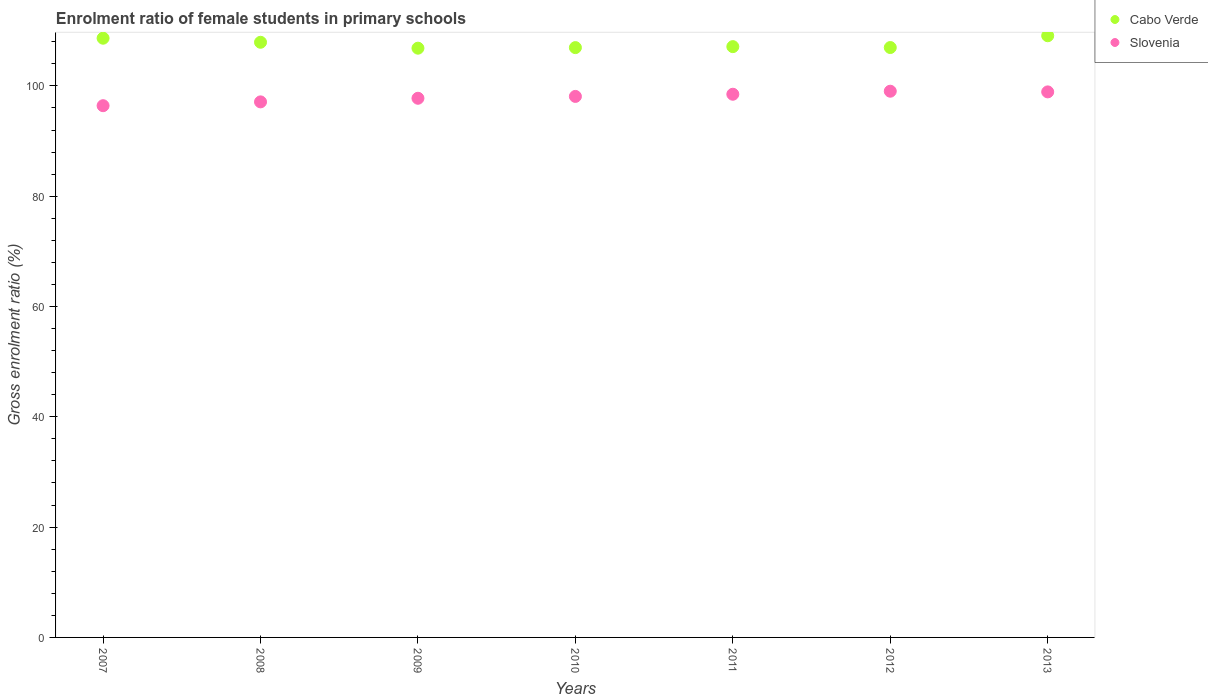What is the enrolment ratio of female students in primary schools in Slovenia in 2007?
Your answer should be very brief. 96.41. Across all years, what is the maximum enrolment ratio of female students in primary schools in Slovenia?
Provide a succinct answer. 99.03. Across all years, what is the minimum enrolment ratio of female students in primary schools in Cabo Verde?
Provide a succinct answer. 106.84. What is the total enrolment ratio of female students in primary schools in Cabo Verde in the graph?
Your answer should be compact. 753.49. What is the difference between the enrolment ratio of female students in primary schools in Cabo Verde in 2009 and that in 2010?
Ensure brevity in your answer.  -0.1. What is the difference between the enrolment ratio of female students in primary schools in Slovenia in 2013 and the enrolment ratio of female students in primary schools in Cabo Verde in 2008?
Give a very brief answer. -9. What is the average enrolment ratio of female students in primary schools in Cabo Verde per year?
Provide a short and direct response. 107.64. In the year 2007, what is the difference between the enrolment ratio of female students in primary schools in Cabo Verde and enrolment ratio of female students in primary schools in Slovenia?
Keep it short and to the point. 12.23. What is the ratio of the enrolment ratio of female students in primary schools in Cabo Verde in 2007 to that in 2010?
Your answer should be very brief. 1.02. What is the difference between the highest and the second highest enrolment ratio of female students in primary schools in Cabo Verde?
Give a very brief answer. 0.45. What is the difference between the highest and the lowest enrolment ratio of female students in primary schools in Cabo Verde?
Your response must be concise. 2.25. In how many years, is the enrolment ratio of female students in primary schools in Cabo Verde greater than the average enrolment ratio of female students in primary schools in Cabo Verde taken over all years?
Ensure brevity in your answer.  3. Is the sum of the enrolment ratio of female students in primary schools in Cabo Verde in 2007 and 2013 greater than the maximum enrolment ratio of female students in primary schools in Slovenia across all years?
Keep it short and to the point. Yes. Is the enrolment ratio of female students in primary schools in Cabo Verde strictly greater than the enrolment ratio of female students in primary schools in Slovenia over the years?
Provide a succinct answer. Yes. Is the enrolment ratio of female students in primary schools in Slovenia strictly less than the enrolment ratio of female students in primary schools in Cabo Verde over the years?
Your answer should be very brief. Yes. What is the difference between two consecutive major ticks on the Y-axis?
Give a very brief answer. 20. Are the values on the major ticks of Y-axis written in scientific E-notation?
Provide a short and direct response. No. Does the graph contain any zero values?
Make the answer very short. No. What is the title of the graph?
Ensure brevity in your answer.  Enrolment ratio of female students in primary schools. Does "Euro area" appear as one of the legend labels in the graph?
Ensure brevity in your answer.  No. What is the label or title of the X-axis?
Provide a succinct answer. Years. What is the label or title of the Y-axis?
Your response must be concise. Gross enrolment ratio (%). What is the Gross enrolment ratio (%) in Cabo Verde in 2007?
Give a very brief answer. 108.64. What is the Gross enrolment ratio (%) of Slovenia in 2007?
Offer a terse response. 96.41. What is the Gross enrolment ratio (%) in Cabo Verde in 2008?
Keep it short and to the point. 107.91. What is the Gross enrolment ratio (%) in Slovenia in 2008?
Your answer should be very brief. 97.1. What is the Gross enrolment ratio (%) of Cabo Verde in 2009?
Your answer should be very brief. 106.84. What is the Gross enrolment ratio (%) of Slovenia in 2009?
Make the answer very short. 97.75. What is the Gross enrolment ratio (%) in Cabo Verde in 2010?
Provide a succinct answer. 106.94. What is the Gross enrolment ratio (%) in Slovenia in 2010?
Ensure brevity in your answer.  98.09. What is the Gross enrolment ratio (%) in Cabo Verde in 2011?
Your response must be concise. 107.12. What is the Gross enrolment ratio (%) in Slovenia in 2011?
Your answer should be compact. 98.48. What is the Gross enrolment ratio (%) of Cabo Verde in 2012?
Provide a short and direct response. 106.95. What is the Gross enrolment ratio (%) in Slovenia in 2012?
Offer a very short reply. 99.03. What is the Gross enrolment ratio (%) of Cabo Verde in 2013?
Give a very brief answer. 109.09. What is the Gross enrolment ratio (%) in Slovenia in 2013?
Your answer should be very brief. 98.91. Across all years, what is the maximum Gross enrolment ratio (%) of Cabo Verde?
Ensure brevity in your answer.  109.09. Across all years, what is the maximum Gross enrolment ratio (%) of Slovenia?
Keep it short and to the point. 99.03. Across all years, what is the minimum Gross enrolment ratio (%) in Cabo Verde?
Offer a very short reply. 106.84. Across all years, what is the minimum Gross enrolment ratio (%) of Slovenia?
Provide a short and direct response. 96.41. What is the total Gross enrolment ratio (%) in Cabo Verde in the graph?
Your answer should be very brief. 753.49. What is the total Gross enrolment ratio (%) in Slovenia in the graph?
Make the answer very short. 685.78. What is the difference between the Gross enrolment ratio (%) in Cabo Verde in 2007 and that in 2008?
Ensure brevity in your answer.  0.74. What is the difference between the Gross enrolment ratio (%) in Slovenia in 2007 and that in 2008?
Make the answer very short. -0.69. What is the difference between the Gross enrolment ratio (%) in Cabo Verde in 2007 and that in 2009?
Provide a succinct answer. 1.81. What is the difference between the Gross enrolment ratio (%) of Slovenia in 2007 and that in 2009?
Provide a short and direct response. -1.35. What is the difference between the Gross enrolment ratio (%) of Cabo Verde in 2007 and that in 2010?
Your answer should be compact. 1.7. What is the difference between the Gross enrolment ratio (%) in Slovenia in 2007 and that in 2010?
Your answer should be very brief. -1.68. What is the difference between the Gross enrolment ratio (%) of Cabo Verde in 2007 and that in 2011?
Provide a short and direct response. 1.53. What is the difference between the Gross enrolment ratio (%) of Slovenia in 2007 and that in 2011?
Keep it short and to the point. -2.07. What is the difference between the Gross enrolment ratio (%) in Cabo Verde in 2007 and that in 2012?
Your answer should be very brief. 1.69. What is the difference between the Gross enrolment ratio (%) in Slovenia in 2007 and that in 2012?
Keep it short and to the point. -2.62. What is the difference between the Gross enrolment ratio (%) in Cabo Verde in 2007 and that in 2013?
Provide a short and direct response. -0.45. What is the difference between the Gross enrolment ratio (%) in Slovenia in 2007 and that in 2013?
Make the answer very short. -2.5. What is the difference between the Gross enrolment ratio (%) in Cabo Verde in 2008 and that in 2009?
Your answer should be compact. 1.07. What is the difference between the Gross enrolment ratio (%) of Slovenia in 2008 and that in 2009?
Give a very brief answer. -0.65. What is the difference between the Gross enrolment ratio (%) in Cabo Verde in 2008 and that in 2010?
Make the answer very short. 0.97. What is the difference between the Gross enrolment ratio (%) of Slovenia in 2008 and that in 2010?
Offer a terse response. -0.99. What is the difference between the Gross enrolment ratio (%) in Cabo Verde in 2008 and that in 2011?
Give a very brief answer. 0.79. What is the difference between the Gross enrolment ratio (%) of Slovenia in 2008 and that in 2011?
Make the answer very short. -1.38. What is the difference between the Gross enrolment ratio (%) in Cabo Verde in 2008 and that in 2012?
Make the answer very short. 0.95. What is the difference between the Gross enrolment ratio (%) of Slovenia in 2008 and that in 2012?
Your answer should be compact. -1.93. What is the difference between the Gross enrolment ratio (%) in Cabo Verde in 2008 and that in 2013?
Give a very brief answer. -1.18. What is the difference between the Gross enrolment ratio (%) of Slovenia in 2008 and that in 2013?
Provide a short and direct response. -1.81. What is the difference between the Gross enrolment ratio (%) in Cabo Verde in 2009 and that in 2010?
Make the answer very short. -0.1. What is the difference between the Gross enrolment ratio (%) of Slovenia in 2009 and that in 2010?
Your answer should be very brief. -0.34. What is the difference between the Gross enrolment ratio (%) in Cabo Verde in 2009 and that in 2011?
Offer a very short reply. -0.28. What is the difference between the Gross enrolment ratio (%) of Slovenia in 2009 and that in 2011?
Your response must be concise. -0.73. What is the difference between the Gross enrolment ratio (%) of Cabo Verde in 2009 and that in 2012?
Your answer should be compact. -0.12. What is the difference between the Gross enrolment ratio (%) in Slovenia in 2009 and that in 2012?
Provide a short and direct response. -1.28. What is the difference between the Gross enrolment ratio (%) of Cabo Verde in 2009 and that in 2013?
Your response must be concise. -2.25. What is the difference between the Gross enrolment ratio (%) in Slovenia in 2009 and that in 2013?
Offer a very short reply. -1.16. What is the difference between the Gross enrolment ratio (%) of Cabo Verde in 2010 and that in 2011?
Your response must be concise. -0.18. What is the difference between the Gross enrolment ratio (%) in Slovenia in 2010 and that in 2011?
Provide a succinct answer. -0.39. What is the difference between the Gross enrolment ratio (%) in Cabo Verde in 2010 and that in 2012?
Your answer should be very brief. -0.01. What is the difference between the Gross enrolment ratio (%) in Slovenia in 2010 and that in 2012?
Ensure brevity in your answer.  -0.94. What is the difference between the Gross enrolment ratio (%) of Cabo Verde in 2010 and that in 2013?
Offer a terse response. -2.15. What is the difference between the Gross enrolment ratio (%) in Slovenia in 2010 and that in 2013?
Your response must be concise. -0.82. What is the difference between the Gross enrolment ratio (%) in Cabo Verde in 2011 and that in 2012?
Offer a terse response. 0.16. What is the difference between the Gross enrolment ratio (%) of Slovenia in 2011 and that in 2012?
Provide a short and direct response. -0.55. What is the difference between the Gross enrolment ratio (%) in Cabo Verde in 2011 and that in 2013?
Give a very brief answer. -1.97. What is the difference between the Gross enrolment ratio (%) of Slovenia in 2011 and that in 2013?
Provide a succinct answer. -0.43. What is the difference between the Gross enrolment ratio (%) of Cabo Verde in 2012 and that in 2013?
Provide a short and direct response. -2.14. What is the difference between the Gross enrolment ratio (%) of Slovenia in 2012 and that in 2013?
Offer a very short reply. 0.12. What is the difference between the Gross enrolment ratio (%) in Cabo Verde in 2007 and the Gross enrolment ratio (%) in Slovenia in 2008?
Your answer should be compact. 11.54. What is the difference between the Gross enrolment ratio (%) of Cabo Verde in 2007 and the Gross enrolment ratio (%) of Slovenia in 2009?
Give a very brief answer. 10.89. What is the difference between the Gross enrolment ratio (%) of Cabo Verde in 2007 and the Gross enrolment ratio (%) of Slovenia in 2010?
Your answer should be compact. 10.55. What is the difference between the Gross enrolment ratio (%) in Cabo Verde in 2007 and the Gross enrolment ratio (%) in Slovenia in 2011?
Offer a very short reply. 10.16. What is the difference between the Gross enrolment ratio (%) of Cabo Verde in 2007 and the Gross enrolment ratio (%) of Slovenia in 2012?
Ensure brevity in your answer.  9.61. What is the difference between the Gross enrolment ratio (%) of Cabo Verde in 2007 and the Gross enrolment ratio (%) of Slovenia in 2013?
Ensure brevity in your answer.  9.73. What is the difference between the Gross enrolment ratio (%) of Cabo Verde in 2008 and the Gross enrolment ratio (%) of Slovenia in 2009?
Keep it short and to the point. 10.15. What is the difference between the Gross enrolment ratio (%) of Cabo Verde in 2008 and the Gross enrolment ratio (%) of Slovenia in 2010?
Make the answer very short. 9.82. What is the difference between the Gross enrolment ratio (%) in Cabo Verde in 2008 and the Gross enrolment ratio (%) in Slovenia in 2011?
Your response must be concise. 9.42. What is the difference between the Gross enrolment ratio (%) of Cabo Verde in 2008 and the Gross enrolment ratio (%) of Slovenia in 2012?
Keep it short and to the point. 8.88. What is the difference between the Gross enrolment ratio (%) in Cabo Verde in 2008 and the Gross enrolment ratio (%) in Slovenia in 2013?
Your response must be concise. 9. What is the difference between the Gross enrolment ratio (%) in Cabo Verde in 2009 and the Gross enrolment ratio (%) in Slovenia in 2010?
Give a very brief answer. 8.75. What is the difference between the Gross enrolment ratio (%) of Cabo Verde in 2009 and the Gross enrolment ratio (%) of Slovenia in 2011?
Ensure brevity in your answer.  8.35. What is the difference between the Gross enrolment ratio (%) in Cabo Verde in 2009 and the Gross enrolment ratio (%) in Slovenia in 2012?
Make the answer very short. 7.8. What is the difference between the Gross enrolment ratio (%) in Cabo Verde in 2009 and the Gross enrolment ratio (%) in Slovenia in 2013?
Ensure brevity in your answer.  7.92. What is the difference between the Gross enrolment ratio (%) in Cabo Verde in 2010 and the Gross enrolment ratio (%) in Slovenia in 2011?
Your answer should be very brief. 8.46. What is the difference between the Gross enrolment ratio (%) in Cabo Verde in 2010 and the Gross enrolment ratio (%) in Slovenia in 2012?
Your answer should be very brief. 7.91. What is the difference between the Gross enrolment ratio (%) in Cabo Verde in 2010 and the Gross enrolment ratio (%) in Slovenia in 2013?
Ensure brevity in your answer.  8.03. What is the difference between the Gross enrolment ratio (%) of Cabo Verde in 2011 and the Gross enrolment ratio (%) of Slovenia in 2012?
Give a very brief answer. 8.08. What is the difference between the Gross enrolment ratio (%) of Cabo Verde in 2011 and the Gross enrolment ratio (%) of Slovenia in 2013?
Make the answer very short. 8.21. What is the difference between the Gross enrolment ratio (%) of Cabo Verde in 2012 and the Gross enrolment ratio (%) of Slovenia in 2013?
Your answer should be compact. 8.04. What is the average Gross enrolment ratio (%) of Cabo Verde per year?
Your response must be concise. 107.64. What is the average Gross enrolment ratio (%) of Slovenia per year?
Give a very brief answer. 97.97. In the year 2007, what is the difference between the Gross enrolment ratio (%) of Cabo Verde and Gross enrolment ratio (%) of Slovenia?
Keep it short and to the point. 12.23. In the year 2008, what is the difference between the Gross enrolment ratio (%) of Cabo Verde and Gross enrolment ratio (%) of Slovenia?
Keep it short and to the point. 10.81. In the year 2009, what is the difference between the Gross enrolment ratio (%) of Cabo Verde and Gross enrolment ratio (%) of Slovenia?
Ensure brevity in your answer.  9.08. In the year 2010, what is the difference between the Gross enrolment ratio (%) of Cabo Verde and Gross enrolment ratio (%) of Slovenia?
Provide a short and direct response. 8.85. In the year 2011, what is the difference between the Gross enrolment ratio (%) of Cabo Verde and Gross enrolment ratio (%) of Slovenia?
Your answer should be very brief. 8.63. In the year 2012, what is the difference between the Gross enrolment ratio (%) in Cabo Verde and Gross enrolment ratio (%) in Slovenia?
Provide a succinct answer. 7.92. In the year 2013, what is the difference between the Gross enrolment ratio (%) in Cabo Verde and Gross enrolment ratio (%) in Slovenia?
Your answer should be very brief. 10.18. What is the ratio of the Gross enrolment ratio (%) in Cabo Verde in 2007 to that in 2008?
Make the answer very short. 1.01. What is the ratio of the Gross enrolment ratio (%) of Slovenia in 2007 to that in 2008?
Your answer should be compact. 0.99. What is the ratio of the Gross enrolment ratio (%) of Cabo Verde in 2007 to that in 2009?
Provide a succinct answer. 1.02. What is the ratio of the Gross enrolment ratio (%) in Slovenia in 2007 to that in 2009?
Provide a succinct answer. 0.99. What is the ratio of the Gross enrolment ratio (%) in Cabo Verde in 2007 to that in 2010?
Offer a terse response. 1.02. What is the ratio of the Gross enrolment ratio (%) in Slovenia in 2007 to that in 2010?
Provide a succinct answer. 0.98. What is the ratio of the Gross enrolment ratio (%) of Cabo Verde in 2007 to that in 2011?
Your answer should be compact. 1.01. What is the ratio of the Gross enrolment ratio (%) of Slovenia in 2007 to that in 2011?
Offer a very short reply. 0.98. What is the ratio of the Gross enrolment ratio (%) of Cabo Verde in 2007 to that in 2012?
Offer a very short reply. 1.02. What is the ratio of the Gross enrolment ratio (%) in Slovenia in 2007 to that in 2012?
Keep it short and to the point. 0.97. What is the ratio of the Gross enrolment ratio (%) in Slovenia in 2007 to that in 2013?
Your answer should be very brief. 0.97. What is the ratio of the Gross enrolment ratio (%) of Cabo Verde in 2008 to that in 2009?
Make the answer very short. 1.01. What is the ratio of the Gross enrolment ratio (%) of Slovenia in 2008 to that in 2009?
Provide a succinct answer. 0.99. What is the ratio of the Gross enrolment ratio (%) of Cabo Verde in 2008 to that in 2010?
Give a very brief answer. 1.01. What is the ratio of the Gross enrolment ratio (%) in Cabo Verde in 2008 to that in 2011?
Provide a short and direct response. 1.01. What is the ratio of the Gross enrolment ratio (%) in Cabo Verde in 2008 to that in 2012?
Your response must be concise. 1.01. What is the ratio of the Gross enrolment ratio (%) of Slovenia in 2008 to that in 2012?
Ensure brevity in your answer.  0.98. What is the ratio of the Gross enrolment ratio (%) of Cabo Verde in 2008 to that in 2013?
Provide a succinct answer. 0.99. What is the ratio of the Gross enrolment ratio (%) of Slovenia in 2008 to that in 2013?
Provide a short and direct response. 0.98. What is the ratio of the Gross enrolment ratio (%) of Slovenia in 2009 to that in 2010?
Your answer should be compact. 1. What is the ratio of the Gross enrolment ratio (%) of Slovenia in 2009 to that in 2011?
Your response must be concise. 0.99. What is the ratio of the Gross enrolment ratio (%) in Cabo Verde in 2009 to that in 2012?
Your answer should be compact. 1. What is the ratio of the Gross enrolment ratio (%) of Slovenia in 2009 to that in 2012?
Your answer should be compact. 0.99. What is the ratio of the Gross enrolment ratio (%) in Cabo Verde in 2009 to that in 2013?
Provide a short and direct response. 0.98. What is the ratio of the Gross enrolment ratio (%) in Slovenia in 2009 to that in 2013?
Keep it short and to the point. 0.99. What is the ratio of the Gross enrolment ratio (%) in Cabo Verde in 2010 to that in 2011?
Provide a succinct answer. 1. What is the ratio of the Gross enrolment ratio (%) in Slovenia in 2010 to that in 2011?
Ensure brevity in your answer.  1. What is the ratio of the Gross enrolment ratio (%) of Cabo Verde in 2010 to that in 2013?
Offer a terse response. 0.98. What is the ratio of the Gross enrolment ratio (%) in Cabo Verde in 2011 to that in 2012?
Keep it short and to the point. 1. What is the ratio of the Gross enrolment ratio (%) of Cabo Verde in 2011 to that in 2013?
Make the answer very short. 0.98. What is the ratio of the Gross enrolment ratio (%) in Cabo Verde in 2012 to that in 2013?
Your answer should be compact. 0.98. What is the ratio of the Gross enrolment ratio (%) of Slovenia in 2012 to that in 2013?
Your answer should be very brief. 1. What is the difference between the highest and the second highest Gross enrolment ratio (%) in Cabo Verde?
Your answer should be compact. 0.45. What is the difference between the highest and the second highest Gross enrolment ratio (%) of Slovenia?
Make the answer very short. 0.12. What is the difference between the highest and the lowest Gross enrolment ratio (%) of Cabo Verde?
Your answer should be very brief. 2.25. What is the difference between the highest and the lowest Gross enrolment ratio (%) in Slovenia?
Provide a succinct answer. 2.62. 